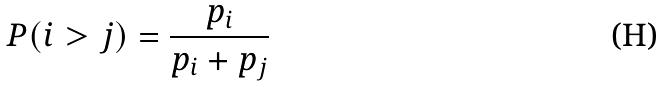Convert formula to latex. <formula><loc_0><loc_0><loc_500><loc_500>P ( i > j ) = \frac { p _ { i } } { p _ { i } + p _ { j } }</formula> 